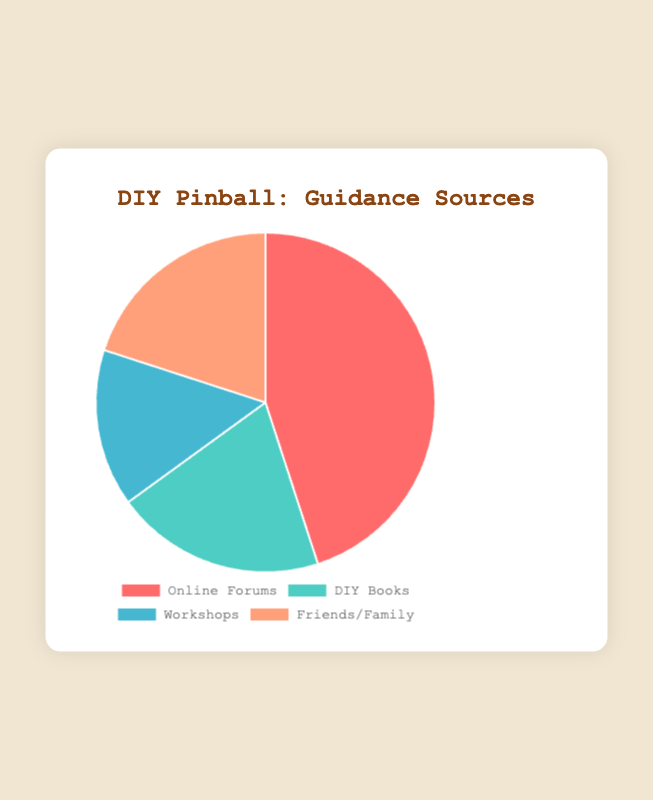Which source is most frequently referred to for guidance? The pie chart shows that the 'Online Forums' section has the largest slice, indicating it is the most frequently used source.
Answer: Online Forums What percentage of guidance is sought from DIY Books and Workshops combined? Adding the percentages from DIY Books (20%) and Workshops (15%) together, the total is 20% + 15% = 35%.
Answer: 35% How does the frequency of seeking guidance from Friends/Family compare to DIY Books? Both 'Friends/Family' and 'DIY Books' have the same percentage of 20%, indicating equal frequency.
Answer: Equal If you combine the frequency percentages of Online Forums and Workshops, how does it compare to the total percentage of the other two sources? The combined frequency of Online Forums and Workshops is 45% + 15% = 60%. The combined frequency of DIY Books and Friends/Family is 20% + 20% = 40%. 60% > 40%, so the first combination is higher.
Answer: Higher Which guidance source has the smallest slice in the pie chart? Observing the chart, the Workshops section has the smallest slice.
Answer: Workshops What is the difference in percentage points between the most frequent and the least frequent guidance sources? The most frequent is Online Forums (45%) and the least frequent is Workshops (15%). The difference is 45% - 15% = 30%.
Answer: 30% What proportion of guidance is sought from sources other than Online Forums? The percentage for Online Forums is 45%, so the remainder is 100% - 45% = 55%.
Answer: 55% What colors represent the highest and lowest frequency guidance sources? The slice for the highest frequency source (Online Forums) is red, and for the lowest frequency source (Workshops) is blue.
Answer: Red; Blue Between Friends/Family and Workshops, which guidance source is more frequently used and by how much? Friends/Family is used by 20% while Workshops account for 15%, so Friends/Family is more frequently used by 20% - 15% = 5%.
Answer: Friends/Family by 5% Compare the frequencies of guidance sought from DIY Books to Online Forums using a ratio. The frequency of DIY Books is 20%, and Online Forums is 45%. The ratio is 20:45, which can be simplified to 4:9.
Answer: 4:9 